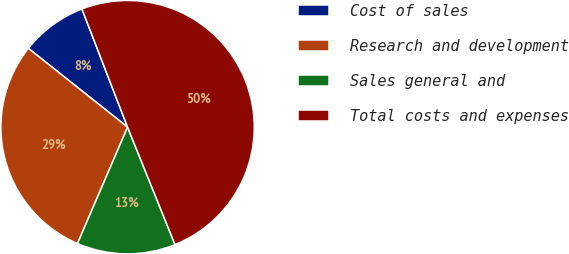Convert chart to OTSL. <chart><loc_0><loc_0><loc_500><loc_500><pie_chart><fcel>Cost of sales<fcel>Research and development<fcel>Sales general and<fcel>Total costs and expenses<nl><fcel>8.45%<fcel>29.22%<fcel>12.58%<fcel>49.76%<nl></chart> 